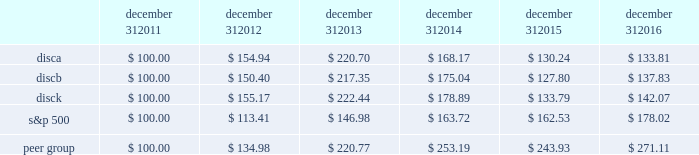December 31 , december 31 , december 31 , december 31 , december 31 , december 31 .
Equity compensation plan information information regarding securities authorized for issuance under equity compensation plans will be set forth in our definitive proxy statement for our 2017 annual meeting of stockholders under the caption 201csecurities authorized for issuance under equity compensation plans , 201d which is incorporated herein by reference .
Item 6 .
Selected financial data .
The table set forth below presents our selected financial information for each of the past five years ( in millions , except per share amounts ) .
The selected statement of operations information for each of the three years ended december 31 , 2016 and the selected balance sheet information as of december 31 , 2016 and 2015 have been derived from and should be read in conjunction with the information in item 7 , 201cmanagement 2019s discussion and analysis of financial condition and results of operations , 201d the audited consolidated financial statements included in item 8 , 201cfinancial statements and supplementary data , 201d and other financial information included elsewhere in this annual report on form 10-k .
The selected statement of operations information for each of the two years ended december 31 , 2013 and 2012 and the selected balance sheet information as of december 31 , 2014 , 2013 and 2012 have been derived from financial statements not included in this annual report on form 10-k .
2016 2015 2014 2013 2012 selected statement of operations information : revenues $ 6497 $ 6394 $ 6265 $ 5535 $ 4487 operating income 2058 1985 2061 1975 1859 income from continuing operations , net of taxes 1218 1048 1137 1077 956 loss from discontinued operations , net of taxes 2014 2014 2014 2014 ( 11 ) net income 1218 1048 1137 1077 945 net income available to discovery communications , inc .
1194 1034 1139 1075 943 basic earnings per share available to discovery communications , inc .
Series a , b and c common stockholders : continuing operations $ 1.97 $ 1.59 $ 1.67 $ 1.50 $ 1.27 discontinued operations 2014 2014 2014 2014 ( 0.01 ) net income 1.97 1.59 1.67 1.50 1.25 diluted earnings per share available to discovery communications , inc .
Series a , b and c common stockholders : continuing operations $ 1.96 $ 1.58 $ 1.66 $ 1.49 $ 1.26 discontinued operations 2014 2014 2014 2014 ( 0.01 ) net income 1.96 1.58 1.66 1.49 1.24 weighted average shares outstanding : basic 401 432 454 484 498 diluted 610 656 687 722 759 selected balance sheet information : cash and cash equivalents $ 300 $ 390 $ 367 $ 408 $ 1201 total assets 15758 15864 15970 14934 12892 long-term debt : current portion 82 119 1107 17 31 long-term portion 7841 7616 6002 6437 5174 total liabilities 10348 10172 9619 8701 6599 redeemable noncontrolling interests 243 241 747 36 2014 equity attributable to discovery communications , inc .
5167 5451 5602 6196 6291 total equity $ 5167 $ 5451 $ 5604 $ 6197 $ 6293 2022 income per share amounts may not sum since each is calculated independently .
2022 on september 30 , 2016 , the company recorded an other-than-temporary impairment of $ 62 million related to its investment in lionsgate .
On december 2 , 2016 , the company acquired a 39% ( 39 % ) minority interest in group nine media , a newly formed media holding company , in exchange for contributions of $ 100 million and the company's digital network businesses seeker and sourcefed , resulting in a gain of $ 50 million upon deconsolidation of the businesses .
( see note 4 to the accompanying consolidated financial statements. ) .
What was the percentage cumulative total shareholder return on discb for the five year period ended december 31 , 2016? 
Computations: ((137.83 - 100) / 100)
Answer: 0.3783. 